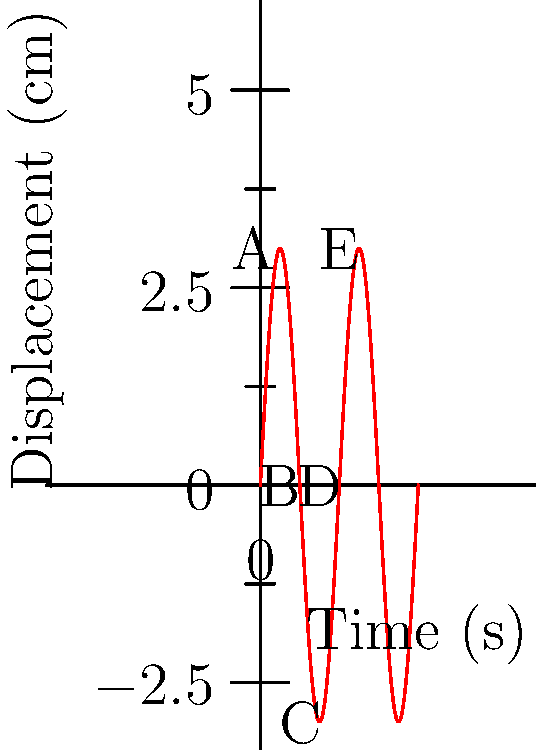In a diversity training session, you're using a pendulum to demonstrate the concept of oscillation and its relevance to workplace dynamics. The displacement-time graph of the pendulum's motion is shown above. If the pendulum completes one full oscillation in 1 second, what is its frequency in Hz? To solve this problem, let's follow these steps:

1. Understand the concept of frequency:
   Frequency is the number of complete oscillations per unit time.

2. Identify the period from the graph:
   The period (T) is the time taken for one complete oscillation.
   From the graph, we can see that one complete oscillation (from A to E) takes 1 second.

3. Recall the relationship between frequency (f) and period (T):
   $$f = \frac{1}{T}$$

4. Calculate the frequency:
   $$f = \frac{1}{T} = \frac{1}{1\text{ s}} = 1\text{ Hz}$$

Therefore, the frequency of the pendulum's oscillation is 1 Hz.
Answer: 1 Hz 